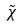<formula> <loc_0><loc_0><loc_500><loc_500>\tilde { \chi }</formula> 